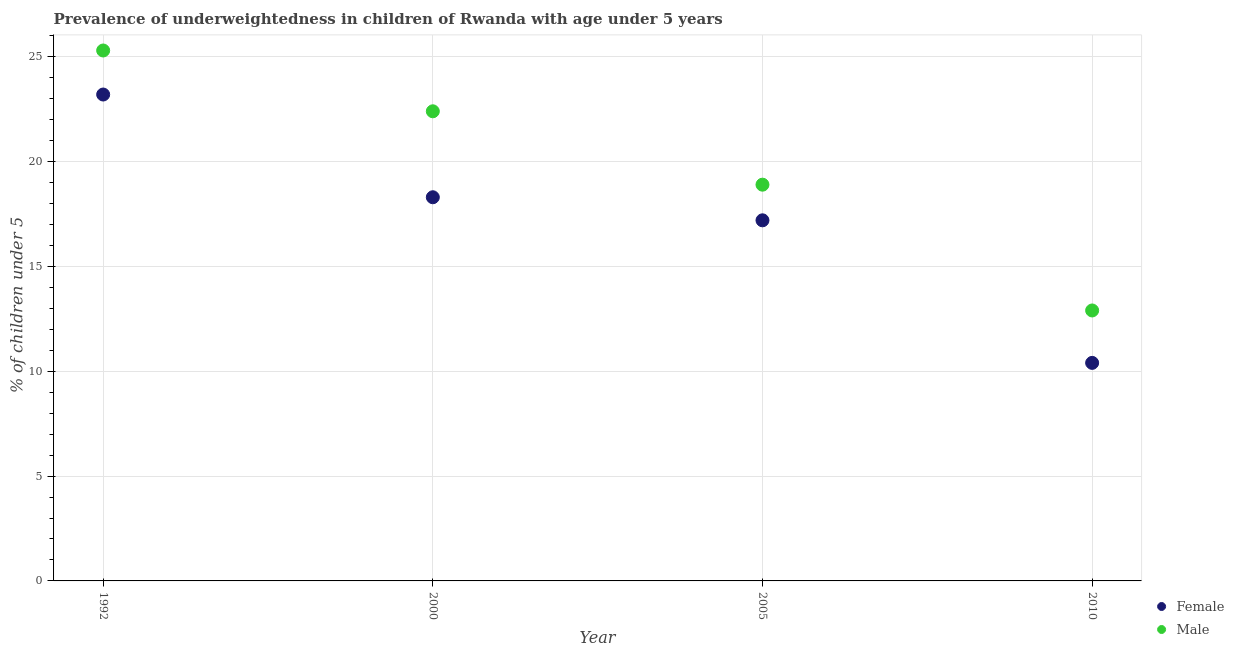How many different coloured dotlines are there?
Provide a succinct answer. 2. Is the number of dotlines equal to the number of legend labels?
Make the answer very short. Yes. What is the percentage of underweighted male children in 2000?
Your response must be concise. 22.4. Across all years, what is the maximum percentage of underweighted female children?
Offer a very short reply. 23.2. Across all years, what is the minimum percentage of underweighted female children?
Ensure brevity in your answer.  10.4. In which year was the percentage of underweighted male children maximum?
Offer a terse response. 1992. What is the total percentage of underweighted male children in the graph?
Provide a short and direct response. 79.5. What is the difference between the percentage of underweighted male children in 2000 and that in 2005?
Offer a terse response. 3.5. What is the difference between the percentage of underweighted female children in 2010 and the percentage of underweighted male children in 1992?
Offer a very short reply. -14.9. What is the average percentage of underweighted female children per year?
Provide a short and direct response. 17.28. In the year 2000, what is the difference between the percentage of underweighted male children and percentage of underweighted female children?
Keep it short and to the point. 4.1. What is the ratio of the percentage of underweighted male children in 1992 to that in 2000?
Make the answer very short. 1.13. What is the difference between the highest and the second highest percentage of underweighted female children?
Your answer should be compact. 4.9. What is the difference between the highest and the lowest percentage of underweighted female children?
Your answer should be very brief. 12.8. In how many years, is the percentage of underweighted female children greater than the average percentage of underweighted female children taken over all years?
Keep it short and to the point. 2. Is the sum of the percentage of underweighted female children in 2000 and 2010 greater than the maximum percentage of underweighted male children across all years?
Your answer should be very brief. Yes. Does the percentage of underweighted male children monotonically increase over the years?
Ensure brevity in your answer.  No. Is the percentage of underweighted male children strictly greater than the percentage of underweighted female children over the years?
Ensure brevity in your answer.  Yes. Is the percentage of underweighted female children strictly less than the percentage of underweighted male children over the years?
Provide a short and direct response. Yes. How many dotlines are there?
Ensure brevity in your answer.  2. How many years are there in the graph?
Your answer should be very brief. 4. What is the difference between two consecutive major ticks on the Y-axis?
Your answer should be compact. 5. Are the values on the major ticks of Y-axis written in scientific E-notation?
Your answer should be very brief. No. Does the graph contain grids?
Keep it short and to the point. Yes. How many legend labels are there?
Your answer should be compact. 2. How are the legend labels stacked?
Offer a terse response. Vertical. What is the title of the graph?
Offer a terse response. Prevalence of underweightedness in children of Rwanda with age under 5 years. What is the label or title of the Y-axis?
Make the answer very short.  % of children under 5. What is the  % of children under 5 in Female in 1992?
Your response must be concise. 23.2. What is the  % of children under 5 of Male in 1992?
Provide a short and direct response. 25.3. What is the  % of children under 5 of Female in 2000?
Provide a short and direct response. 18.3. What is the  % of children under 5 in Male in 2000?
Provide a succinct answer. 22.4. What is the  % of children under 5 in Female in 2005?
Keep it short and to the point. 17.2. What is the  % of children under 5 in Male in 2005?
Offer a terse response. 18.9. What is the  % of children under 5 in Female in 2010?
Provide a succinct answer. 10.4. What is the  % of children under 5 of Male in 2010?
Keep it short and to the point. 12.9. Across all years, what is the maximum  % of children under 5 in Female?
Your answer should be very brief. 23.2. Across all years, what is the maximum  % of children under 5 of Male?
Your answer should be very brief. 25.3. Across all years, what is the minimum  % of children under 5 of Female?
Your answer should be compact. 10.4. Across all years, what is the minimum  % of children under 5 in Male?
Your answer should be compact. 12.9. What is the total  % of children under 5 of Female in the graph?
Provide a succinct answer. 69.1. What is the total  % of children under 5 of Male in the graph?
Make the answer very short. 79.5. What is the difference between the  % of children under 5 in Male in 1992 and that in 2000?
Give a very brief answer. 2.9. What is the difference between the  % of children under 5 of Male in 1992 and that in 2005?
Offer a very short reply. 6.4. What is the difference between the  % of children under 5 in Female in 1992 and that in 2010?
Make the answer very short. 12.8. What is the difference between the  % of children under 5 in Female in 2000 and that in 2005?
Your answer should be compact. 1.1. What is the difference between the  % of children under 5 of Female in 2000 and that in 2010?
Offer a very short reply. 7.9. What is the difference between the  % of children under 5 in Male in 2000 and that in 2010?
Your response must be concise. 9.5. What is the difference between the  % of children under 5 of Male in 2005 and that in 2010?
Your answer should be compact. 6. What is the difference between the  % of children under 5 of Female in 2000 and the  % of children under 5 of Male in 2005?
Your answer should be compact. -0.6. What is the difference between the  % of children under 5 in Female in 2000 and the  % of children under 5 in Male in 2010?
Your response must be concise. 5.4. What is the difference between the  % of children under 5 of Female in 2005 and the  % of children under 5 of Male in 2010?
Offer a terse response. 4.3. What is the average  % of children under 5 in Female per year?
Your answer should be compact. 17.27. What is the average  % of children under 5 of Male per year?
Your answer should be compact. 19.88. In the year 1992, what is the difference between the  % of children under 5 of Female and  % of children under 5 of Male?
Keep it short and to the point. -2.1. In the year 2000, what is the difference between the  % of children under 5 of Female and  % of children under 5 of Male?
Your answer should be compact. -4.1. In the year 2005, what is the difference between the  % of children under 5 in Female and  % of children under 5 in Male?
Your response must be concise. -1.7. In the year 2010, what is the difference between the  % of children under 5 in Female and  % of children under 5 in Male?
Keep it short and to the point. -2.5. What is the ratio of the  % of children under 5 of Female in 1992 to that in 2000?
Your answer should be compact. 1.27. What is the ratio of the  % of children under 5 in Male in 1992 to that in 2000?
Offer a terse response. 1.13. What is the ratio of the  % of children under 5 of Female in 1992 to that in 2005?
Provide a succinct answer. 1.35. What is the ratio of the  % of children under 5 of Male in 1992 to that in 2005?
Provide a succinct answer. 1.34. What is the ratio of the  % of children under 5 in Female in 1992 to that in 2010?
Your answer should be compact. 2.23. What is the ratio of the  % of children under 5 of Male in 1992 to that in 2010?
Give a very brief answer. 1.96. What is the ratio of the  % of children under 5 in Female in 2000 to that in 2005?
Give a very brief answer. 1.06. What is the ratio of the  % of children under 5 in Male in 2000 to that in 2005?
Keep it short and to the point. 1.19. What is the ratio of the  % of children under 5 in Female in 2000 to that in 2010?
Provide a succinct answer. 1.76. What is the ratio of the  % of children under 5 of Male in 2000 to that in 2010?
Ensure brevity in your answer.  1.74. What is the ratio of the  % of children under 5 of Female in 2005 to that in 2010?
Make the answer very short. 1.65. What is the ratio of the  % of children under 5 of Male in 2005 to that in 2010?
Make the answer very short. 1.47. What is the difference between the highest and the second highest  % of children under 5 in Female?
Provide a short and direct response. 4.9. What is the difference between the highest and the lowest  % of children under 5 in Female?
Offer a terse response. 12.8. What is the difference between the highest and the lowest  % of children under 5 in Male?
Ensure brevity in your answer.  12.4. 